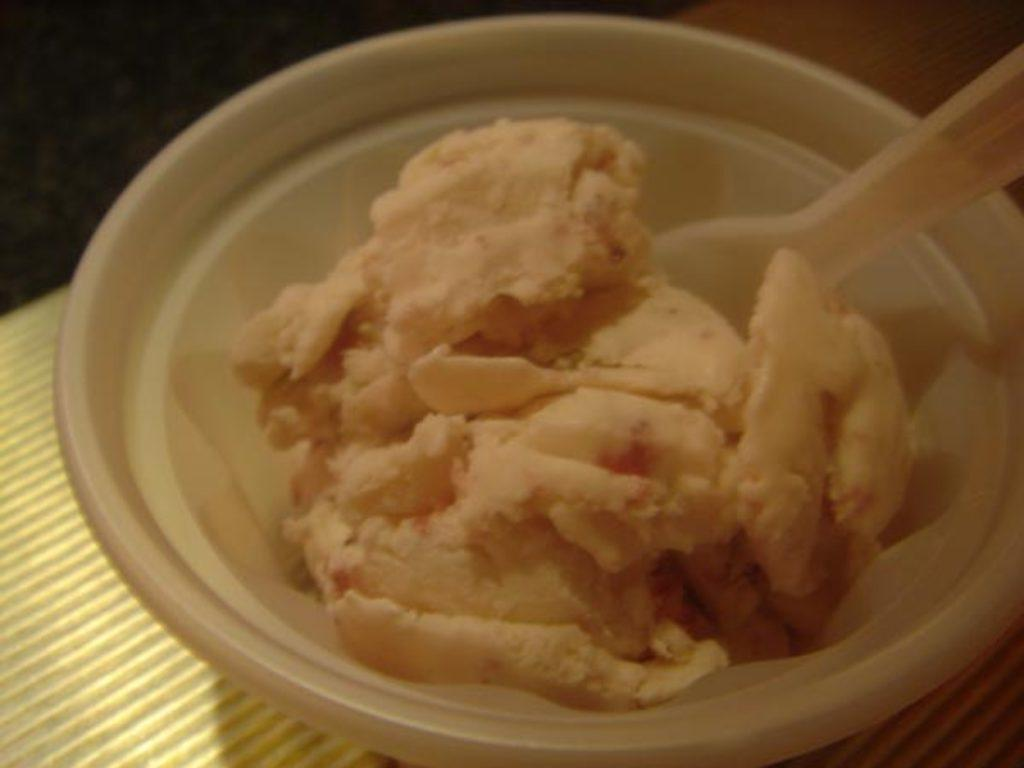What is in the bowl that is visible in the image? There is an ice cream in the bowl in the image. What is located at the bottom of the image? There is a table at the bottom of the image. What type of flag is being used as a thread to swing the ice cream in the image? There is no flag or swing present in the image; it features an ice cream in a bowl and a table. 